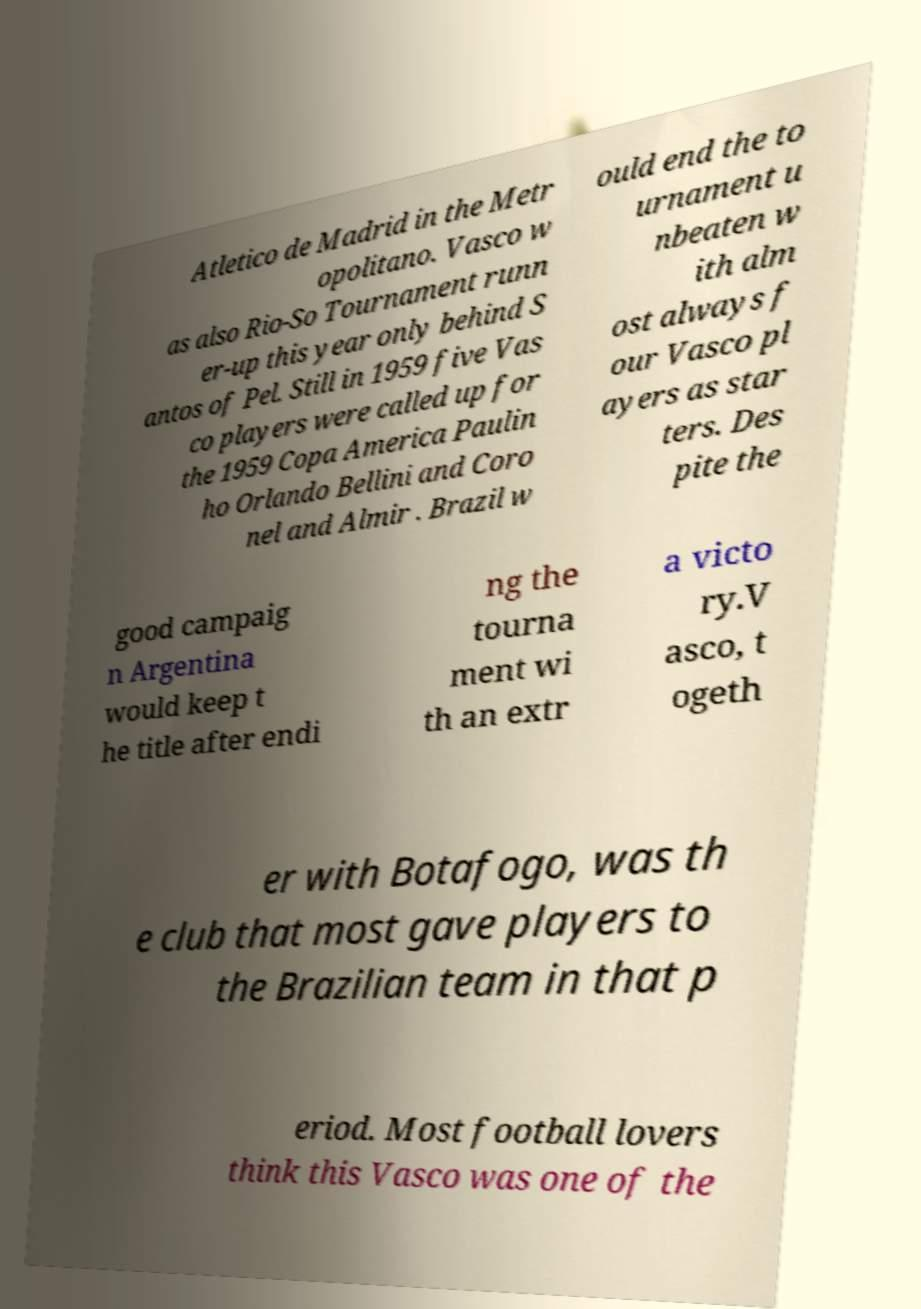Could you extract and type out the text from this image? Atletico de Madrid in the Metr opolitano. Vasco w as also Rio-So Tournament runn er-up this year only behind S antos of Pel. Still in 1959 five Vas co players were called up for the 1959 Copa America Paulin ho Orlando Bellini and Coro nel and Almir . Brazil w ould end the to urnament u nbeaten w ith alm ost always f our Vasco pl ayers as star ters. Des pite the good campaig n Argentina would keep t he title after endi ng the tourna ment wi th an extr a victo ry.V asco, t ogeth er with Botafogo, was th e club that most gave players to the Brazilian team in that p eriod. Most football lovers think this Vasco was one of the 